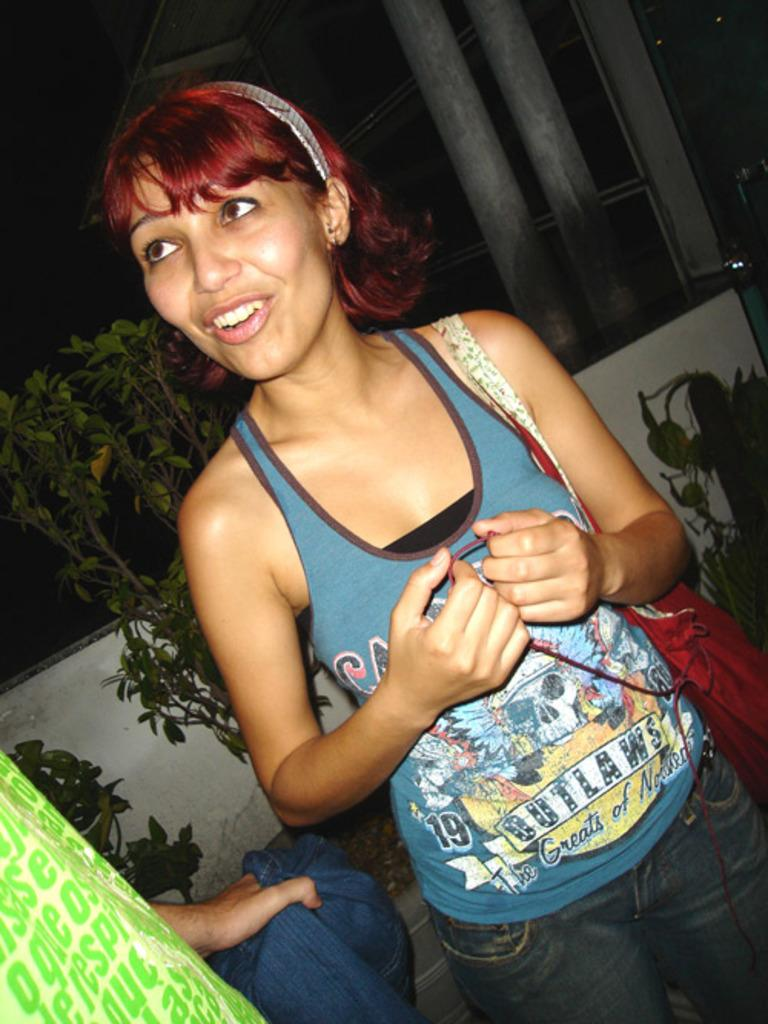Who is present in the image? There is a woman in the image. What is the woman's facial expression? The woman has a smiling face. What type of structure can be seen in the background of the image? There is a boundary wall visible in the image. What type of vegetation is present in the image? There are plants in the image. What type of badge is the woman wearing in the image? There is no badge visible on the woman in the image. Can you describe the behavior of the fly in the image? There are no flies present in the image. 